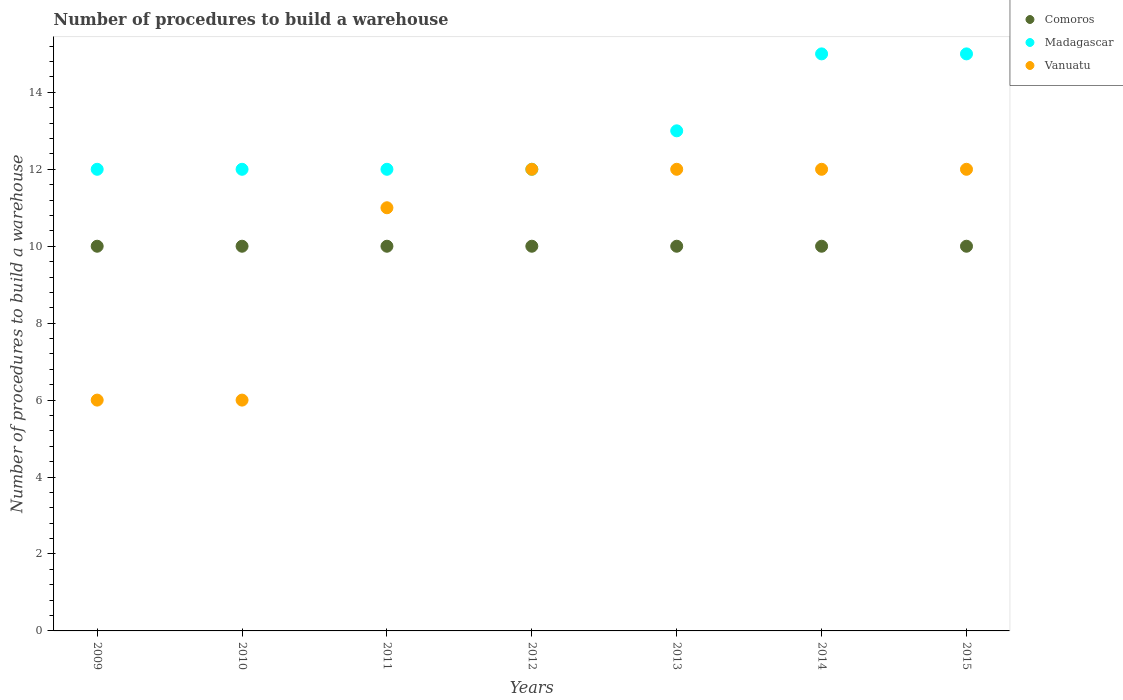Is the number of dotlines equal to the number of legend labels?
Your response must be concise. Yes. What is the number of procedures to build a warehouse in in Comoros in 2009?
Offer a terse response. 10. Across all years, what is the maximum number of procedures to build a warehouse in in Vanuatu?
Provide a succinct answer. 12. Across all years, what is the minimum number of procedures to build a warehouse in in Comoros?
Make the answer very short. 10. In which year was the number of procedures to build a warehouse in in Madagascar minimum?
Your answer should be compact. 2009. What is the total number of procedures to build a warehouse in in Vanuatu in the graph?
Give a very brief answer. 71. What is the difference between the number of procedures to build a warehouse in in Vanuatu in 2011 and that in 2015?
Offer a very short reply. -1. What is the difference between the number of procedures to build a warehouse in in Madagascar in 2015 and the number of procedures to build a warehouse in in Comoros in 2014?
Offer a terse response. 5. What is the average number of procedures to build a warehouse in in Vanuatu per year?
Offer a terse response. 10.14. In the year 2015, what is the difference between the number of procedures to build a warehouse in in Madagascar and number of procedures to build a warehouse in in Vanuatu?
Your response must be concise. 3. In how many years, is the number of procedures to build a warehouse in in Vanuatu greater than 8?
Ensure brevity in your answer.  5. Is the difference between the number of procedures to build a warehouse in in Madagascar in 2013 and 2014 greater than the difference between the number of procedures to build a warehouse in in Vanuatu in 2013 and 2014?
Keep it short and to the point. No. What is the difference between the highest and the second highest number of procedures to build a warehouse in in Comoros?
Your response must be concise. 0. In how many years, is the number of procedures to build a warehouse in in Vanuatu greater than the average number of procedures to build a warehouse in in Vanuatu taken over all years?
Your answer should be compact. 5. Is the sum of the number of procedures to build a warehouse in in Vanuatu in 2011 and 2015 greater than the maximum number of procedures to build a warehouse in in Madagascar across all years?
Your response must be concise. Yes. Is it the case that in every year, the sum of the number of procedures to build a warehouse in in Comoros and number of procedures to build a warehouse in in Madagascar  is greater than the number of procedures to build a warehouse in in Vanuatu?
Your response must be concise. Yes. Does the number of procedures to build a warehouse in in Comoros monotonically increase over the years?
Give a very brief answer. No. Does the graph contain any zero values?
Your answer should be very brief. No. Where does the legend appear in the graph?
Your answer should be very brief. Top right. How many legend labels are there?
Provide a succinct answer. 3. How are the legend labels stacked?
Provide a succinct answer. Vertical. What is the title of the graph?
Your response must be concise. Number of procedures to build a warehouse. Does "Congo (Democratic)" appear as one of the legend labels in the graph?
Make the answer very short. No. What is the label or title of the Y-axis?
Offer a very short reply. Number of procedures to build a warehouse. What is the Number of procedures to build a warehouse of Comoros in 2009?
Make the answer very short. 10. What is the Number of procedures to build a warehouse in Madagascar in 2010?
Give a very brief answer. 12. What is the Number of procedures to build a warehouse of Vanuatu in 2010?
Provide a succinct answer. 6. What is the Number of procedures to build a warehouse in Madagascar in 2011?
Your response must be concise. 12. What is the Number of procedures to build a warehouse of Comoros in 2013?
Offer a terse response. 10. What is the Number of procedures to build a warehouse in Madagascar in 2013?
Your answer should be compact. 13. What is the Number of procedures to build a warehouse of Comoros in 2014?
Give a very brief answer. 10. What is the Number of procedures to build a warehouse in Madagascar in 2014?
Provide a succinct answer. 15. What is the Number of procedures to build a warehouse of Madagascar in 2015?
Your answer should be compact. 15. What is the Number of procedures to build a warehouse in Vanuatu in 2015?
Keep it short and to the point. 12. Across all years, what is the maximum Number of procedures to build a warehouse in Comoros?
Keep it short and to the point. 10. Across all years, what is the minimum Number of procedures to build a warehouse of Vanuatu?
Ensure brevity in your answer.  6. What is the total Number of procedures to build a warehouse in Comoros in the graph?
Offer a terse response. 70. What is the total Number of procedures to build a warehouse of Madagascar in the graph?
Make the answer very short. 91. What is the difference between the Number of procedures to build a warehouse in Madagascar in 2009 and that in 2010?
Give a very brief answer. 0. What is the difference between the Number of procedures to build a warehouse in Comoros in 2009 and that in 2011?
Keep it short and to the point. 0. What is the difference between the Number of procedures to build a warehouse in Comoros in 2009 and that in 2012?
Your response must be concise. 0. What is the difference between the Number of procedures to build a warehouse of Madagascar in 2009 and that in 2012?
Offer a very short reply. 0. What is the difference between the Number of procedures to build a warehouse of Vanuatu in 2009 and that in 2012?
Ensure brevity in your answer.  -6. What is the difference between the Number of procedures to build a warehouse of Comoros in 2009 and that in 2013?
Give a very brief answer. 0. What is the difference between the Number of procedures to build a warehouse in Madagascar in 2009 and that in 2013?
Offer a very short reply. -1. What is the difference between the Number of procedures to build a warehouse of Vanuatu in 2009 and that in 2013?
Your response must be concise. -6. What is the difference between the Number of procedures to build a warehouse in Madagascar in 2009 and that in 2014?
Your answer should be compact. -3. What is the difference between the Number of procedures to build a warehouse in Vanuatu in 2009 and that in 2014?
Ensure brevity in your answer.  -6. What is the difference between the Number of procedures to build a warehouse in Comoros in 2009 and that in 2015?
Provide a short and direct response. 0. What is the difference between the Number of procedures to build a warehouse of Madagascar in 2009 and that in 2015?
Ensure brevity in your answer.  -3. What is the difference between the Number of procedures to build a warehouse in Vanuatu in 2009 and that in 2015?
Ensure brevity in your answer.  -6. What is the difference between the Number of procedures to build a warehouse of Madagascar in 2010 and that in 2011?
Offer a terse response. 0. What is the difference between the Number of procedures to build a warehouse of Madagascar in 2010 and that in 2012?
Make the answer very short. 0. What is the difference between the Number of procedures to build a warehouse of Comoros in 2010 and that in 2013?
Provide a short and direct response. 0. What is the difference between the Number of procedures to build a warehouse in Madagascar in 2010 and that in 2013?
Provide a short and direct response. -1. What is the difference between the Number of procedures to build a warehouse in Comoros in 2010 and that in 2014?
Give a very brief answer. 0. What is the difference between the Number of procedures to build a warehouse of Vanuatu in 2010 and that in 2014?
Keep it short and to the point. -6. What is the difference between the Number of procedures to build a warehouse in Comoros in 2010 and that in 2015?
Provide a succinct answer. 0. What is the difference between the Number of procedures to build a warehouse in Madagascar in 2011 and that in 2012?
Your response must be concise. 0. What is the difference between the Number of procedures to build a warehouse in Vanuatu in 2011 and that in 2012?
Give a very brief answer. -1. What is the difference between the Number of procedures to build a warehouse of Comoros in 2011 and that in 2013?
Your answer should be compact. 0. What is the difference between the Number of procedures to build a warehouse in Vanuatu in 2011 and that in 2013?
Offer a terse response. -1. What is the difference between the Number of procedures to build a warehouse in Madagascar in 2011 and that in 2014?
Provide a succinct answer. -3. What is the difference between the Number of procedures to build a warehouse in Comoros in 2011 and that in 2015?
Your response must be concise. 0. What is the difference between the Number of procedures to build a warehouse in Vanuatu in 2011 and that in 2015?
Your answer should be compact. -1. What is the difference between the Number of procedures to build a warehouse of Madagascar in 2012 and that in 2013?
Provide a short and direct response. -1. What is the difference between the Number of procedures to build a warehouse of Comoros in 2012 and that in 2014?
Your answer should be compact. 0. What is the difference between the Number of procedures to build a warehouse in Madagascar in 2012 and that in 2014?
Ensure brevity in your answer.  -3. What is the difference between the Number of procedures to build a warehouse of Vanuatu in 2012 and that in 2014?
Your answer should be compact. 0. What is the difference between the Number of procedures to build a warehouse of Comoros in 2012 and that in 2015?
Offer a very short reply. 0. What is the difference between the Number of procedures to build a warehouse in Vanuatu in 2013 and that in 2014?
Keep it short and to the point. 0. What is the difference between the Number of procedures to build a warehouse of Vanuatu in 2013 and that in 2015?
Provide a succinct answer. 0. What is the difference between the Number of procedures to build a warehouse of Madagascar in 2014 and that in 2015?
Make the answer very short. 0. What is the difference between the Number of procedures to build a warehouse of Vanuatu in 2014 and that in 2015?
Make the answer very short. 0. What is the difference between the Number of procedures to build a warehouse in Comoros in 2009 and the Number of procedures to build a warehouse in Madagascar in 2010?
Ensure brevity in your answer.  -2. What is the difference between the Number of procedures to build a warehouse in Comoros in 2009 and the Number of procedures to build a warehouse in Vanuatu in 2010?
Your answer should be very brief. 4. What is the difference between the Number of procedures to build a warehouse of Comoros in 2009 and the Number of procedures to build a warehouse of Madagascar in 2011?
Your answer should be compact. -2. What is the difference between the Number of procedures to build a warehouse in Comoros in 2009 and the Number of procedures to build a warehouse in Vanuatu in 2011?
Your answer should be compact. -1. What is the difference between the Number of procedures to build a warehouse of Madagascar in 2009 and the Number of procedures to build a warehouse of Vanuatu in 2012?
Your answer should be very brief. 0. What is the difference between the Number of procedures to build a warehouse of Comoros in 2009 and the Number of procedures to build a warehouse of Madagascar in 2013?
Provide a short and direct response. -3. What is the difference between the Number of procedures to build a warehouse in Comoros in 2009 and the Number of procedures to build a warehouse in Vanuatu in 2013?
Provide a short and direct response. -2. What is the difference between the Number of procedures to build a warehouse in Madagascar in 2009 and the Number of procedures to build a warehouse in Vanuatu in 2013?
Give a very brief answer. 0. What is the difference between the Number of procedures to build a warehouse in Comoros in 2009 and the Number of procedures to build a warehouse in Madagascar in 2014?
Your response must be concise. -5. What is the difference between the Number of procedures to build a warehouse in Comoros in 2009 and the Number of procedures to build a warehouse in Madagascar in 2015?
Give a very brief answer. -5. What is the difference between the Number of procedures to build a warehouse of Madagascar in 2009 and the Number of procedures to build a warehouse of Vanuatu in 2015?
Offer a very short reply. 0. What is the difference between the Number of procedures to build a warehouse of Comoros in 2010 and the Number of procedures to build a warehouse of Vanuatu in 2011?
Your answer should be very brief. -1. What is the difference between the Number of procedures to build a warehouse in Comoros in 2010 and the Number of procedures to build a warehouse in Vanuatu in 2013?
Make the answer very short. -2. What is the difference between the Number of procedures to build a warehouse of Madagascar in 2010 and the Number of procedures to build a warehouse of Vanuatu in 2013?
Offer a terse response. 0. What is the difference between the Number of procedures to build a warehouse in Comoros in 2010 and the Number of procedures to build a warehouse in Vanuatu in 2015?
Make the answer very short. -2. What is the difference between the Number of procedures to build a warehouse in Madagascar in 2010 and the Number of procedures to build a warehouse in Vanuatu in 2015?
Keep it short and to the point. 0. What is the difference between the Number of procedures to build a warehouse in Comoros in 2011 and the Number of procedures to build a warehouse in Madagascar in 2012?
Your answer should be compact. -2. What is the difference between the Number of procedures to build a warehouse of Comoros in 2011 and the Number of procedures to build a warehouse of Madagascar in 2013?
Provide a short and direct response. -3. What is the difference between the Number of procedures to build a warehouse in Madagascar in 2011 and the Number of procedures to build a warehouse in Vanuatu in 2013?
Provide a succinct answer. 0. What is the difference between the Number of procedures to build a warehouse of Comoros in 2011 and the Number of procedures to build a warehouse of Madagascar in 2015?
Your answer should be very brief. -5. What is the difference between the Number of procedures to build a warehouse of Comoros in 2011 and the Number of procedures to build a warehouse of Vanuatu in 2015?
Keep it short and to the point. -2. What is the difference between the Number of procedures to build a warehouse in Madagascar in 2012 and the Number of procedures to build a warehouse in Vanuatu in 2013?
Give a very brief answer. 0. What is the difference between the Number of procedures to build a warehouse in Madagascar in 2012 and the Number of procedures to build a warehouse in Vanuatu in 2014?
Offer a terse response. 0. What is the difference between the Number of procedures to build a warehouse in Comoros in 2012 and the Number of procedures to build a warehouse in Vanuatu in 2015?
Give a very brief answer. -2. What is the difference between the Number of procedures to build a warehouse of Madagascar in 2013 and the Number of procedures to build a warehouse of Vanuatu in 2014?
Keep it short and to the point. 1. What is the difference between the Number of procedures to build a warehouse of Comoros in 2013 and the Number of procedures to build a warehouse of Vanuatu in 2015?
Provide a succinct answer. -2. What is the difference between the Number of procedures to build a warehouse of Madagascar in 2014 and the Number of procedures to build a warehouse of Vanuatu in 2015?
Your answer should be very brief. 3. What is the average Number of procedures to build a warehouse of Madagascar per year?
Keep it short and to the point. 13. What is the average Number of procedures to build a warehouse in Vanuatu per year?
Provide a succinct answer. 10.14. In the year 2009, what is the difference between the Number of procedures to build a warehouse of Comoros and Number of procedures to build a warehouse of Vanuatu?
Ensure brevity in your answer.  4. In the year 2010, what is the difference between the Number of procedures to build a warehouse of Comoros and Number of procedures to build a warehouse of Madagascar?
Your response must be concise. -2. In the year 2010, what is the difference between the Number of procedures to build a warehouse in Comoros and Number of procedures to build a warehouse in Vanuatu?
Offer a very short reply. 4. In the year 2011, what is the difference between the Number of procedures to build a warehouse in Comoros and Number of procedures to build a warehouse in Madagascar?
Make the answer very short. -2. In the year 2012, what is the difference between the Number of procedures to build a warehouse in Comoros and Number of procedures to build a warehouse in Madagascar?
Ensure brevity in your answer.  -2. In the year 2012, what is the difference between the Number of procedures to build a warehouse in Madagascar and Number of procedures to build a warehouse in Vanuatu?
Provide a short and direct response. 0. In the year 2013, what is the difference between the Number of procedures to build a warehouse of Comoros and Number of procedures to build a warehouse of Madagascar?
Offer a very short reply. -3. In the year 2013, what is the difference between the Number of procedures to build a warehouse in Comoros and Number of procedures to build a warehouse in Vanuatu?
Provide a succinct answer. -2. In the year 2013, what is the difference between the Number of procedures to build a warehouse of Madagascar and Number of procedures to build a warehouse of Vanuatu?
Your answer should be very brief. 1. In the year 2014, what is the difference between the Number of procedures to build a warehouse of Comoros and Number of procedures to build a warehouse of Vanuatu?
Your answer should be very brief. -2. In the year 2015, what is the difference between the Number of procedures to build a warehouse of Comoros and Number of procedures to build a warehouse of Madagascar?
Keep it short and to the point. -5. In the year 2015, what is the difference between the Number of procedures to build a warehouse in Madagascar and Number of procedures to build a warehouse in Vanuatu?
Provide a succinct answer. 3. What is the ratio of the Number of procedures to build a warehouse of Vanuatu in 2009 to that in 2010?
Provide a short and direct response. 1. What is the ratio of the Number of procedures to build a warehouse of Madagascar in 2009 to that in 2011?
Give a very brief answer. 1. What is the ratio of the Number of procedures to build a warehouse in Vanuatu in 2009 to that in 2011?
Offer a terse response. 0.55. What is the ratio of the Number of procedures to build a warehouse of Madagascar in 2009 to that in 2012?
Provide a succinct answer. 1. What is the ratio of the Number of procedures to build a warehouse in Madagascar in 2009 to that in 2013?
Make the answer very short. 0.92. What is the ratio of the Number of procedures to build a warehouse in Vanuatu in 2009 to that in 2013?
Ensure brevity in your answer.  0.5. What is the ratio of the Number of procedures to build a warehouse in Madagascar in 2009 to that in 2014?
Give a very brief answer. 0.8. What is the ratio of the Number of procedures to build a warehouse of Vanuatu in 2009 to that in 2015?
Your response must be concise. 0.5. What is the ratio of the Number of procedures to build a warehouse of Comoros in 2010 to that in 2011?
Give a very brief answer. 1. What is the ratio of the Number of procedures to build a warehouse in Madagascar in 2010 to that in 2011?
Provide a short and direct response. 1. What is the ratio of the Number of procedures to build a warehouse of Vanuatu in 2010 to that in 2011?
Ensure brevity in your answer.  0.55. What is the ratio of the Number of procedures to build a warehouse of Madagascar in 2010 to that in 2012?
Give a very brief answer. 1. What is the ratio of the Number of procedures to build a warehouse of Comoros in 2010 to that in 2013?
Provide a short and direct response. 1. What is the ratio of the Number of procedures to build a warehouse in Vanuatu in 2010 to that in 2013?
Make the answer very short. 0.5. What is the ratio of the Number of procedures to build a warehouse of Madagascar in 2010 to that in 2014?
Provide a succinct answer. 0.8. What is the ratio of the Number of procedures to build a warehouse in Vanuatu in 2010 to that in 2014?
Give a very brief answer. 0.5. What is the ratio of the Number of procedures to build a warehouse of Comoros in 2010 to that in 2015?
Offer a terse response. 1. What is the ratio of the Number of procedures to build a warehouse in Madagascar in 2010 to that in 2015?
Your response must be concise. 0.8. What is the ratio of the Number of procedures to build a warehouse of Madagascar in 2011 to that in 2012?
Make the answer very short. 1. What is the ratio of the Number of procedures to build a warehouse of Madagascar in 2011 to that in 2013?
Give a very brief answer. 0.92. What is the ratio of the Number of procedures to build a warehouse in Vanuatu in 2011 to that in 2013?
Give a very brief answer. 0.92. What is the ratio of the Number of procedures to build a warehouse of Comoros in 2011 to that in 2015?
Ensure brevity in your answer.  1. What is the ratio of the Number of procedures to build a warehouse of Madagascar in 2011 to that in 2015?
Provide a short and direct response. 0.8. What is the ratio of the Number of procedures to build a warehouse in Vanuatu in 2011 to that in 2015?
Provide a short and direct response. 0.92. What is the ratio of the Number of procedures to build a warehouse in Comoros in 2012 to that in 2013?
Give a very brief answer. 1. What is the ratio of the Number of procedures to build a warehouse in Madagascar in 2012 to that in 2013?
Your answer should be compact. 0.92. What is the ratio of the Number of procedures to build a warehouse of Vanuatu in 2012 to that in 2013?
Give a very brief answer. 1. What is the ratio of the Number of procedures to build a warehouse in Comoros in 2012 to that in 2014?
Your answer should be compact. 1. What is the ratio of the Number of procedures to build a warehouse in Vanuatu in 2012 to that in 2014?
Ensure brevity in your answer.  1. What is the ratio of the Number of procedures to build a warehouse of Comoros in 2012 to that in 2015?
Ensure brevity in your answer.  1. What is the ratio of the Number of procedures to build a warehouse of Vanuatu in 2012 to that in 2015?
Ensure brevity in your answer.  1. What is the ratio of the Number of procedures to build a warehouse of Madagascar in 2013 to that in 2014?
Offer a very short reply. 0.87. What is the ratio of the Number of procedures to build a warehouse in Vanuatu in 2013 to that in 2014?
Offer a very short reply. 1. What is the ratio of the Number of procedures to build a warehouse of Madagascar in 2013 to that in 2015?
Ensure brevity in your answer.  0.87. What is the ratio of the Number of procedures to build a warehouse in Madagascar in 2014 to that in 2015?
Your answer should be compact. 1. What is the difference between the highest and the lowest Number of procedures to build a warehouse of Vanuatu?
Ensure brevity in your answer.  6. 